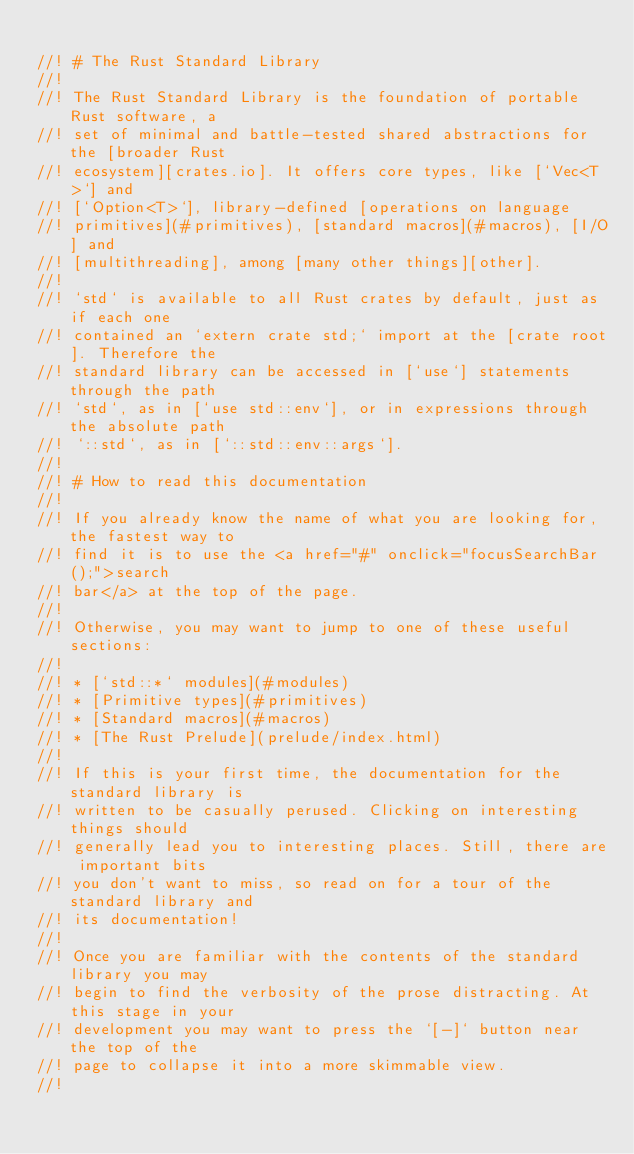Convert code to text. <code><loc_0><loc_0><loc_500><loc_500><_Rust_>
//! # The Rust Standard Library
//!
//! The Rust Standard Library is the foundation of portable Rust software, a
//! set of minimal and battle-tested shared abstractions for the [broader Rust
//! ecosystem][crates.io]. It offers core types, like [`Vec<T>`] and
//! [`Option<T>`], library-defined [operations on language
//! primitives](#primitives), [standard macros](#macros), [I/O] and
//! [multithreading], among [many other things][other].
//!
//! `std` is available to all Rust crates by default, just as if each one
//! contained an `extern crate std;` import at the [crate root]. Therefore the
//! standard library can be accessed in [`use`] statements through the path
//! `std`, as in [`use std::env`], or in expressions through the absolute path
//! `::std`, as in [`::std::env::args`].
//!
//! # How to read this documentation
//!
//! If you already know the name of what you are looking for, the fastest way to
//! find it is to use the <a href="#" onclick="focusSearchBar();">search
//! bar</a> at the top of the page.
//!
//! Otherwise, you may want to jump to one of these useful sections:
//!
//! * [`std::*` modules](#modules)
//! * [Primitive types](#primitives)
//! * [Standard macros](#macros)
//! * [The Rust Prelude](prelude/index.html)
//!
//! If this is your first time, the documentation for the standard library is
//! written to be casually perused. Clicking on interesting things should
//! generally lead you to interesting places. Still, there are important bits
//! you don't want to miss, so read on for a tour of the standard library and
//! its documentation!
//!
//! Once you are familiar with the contents of the standard library you may
//! begin to find the verbosity of the prose distracting. At this stage in your
//! development you may want to press the `[-]` button near the top of the
//! page to collapse it into a more skimmable view.
//!</code> 